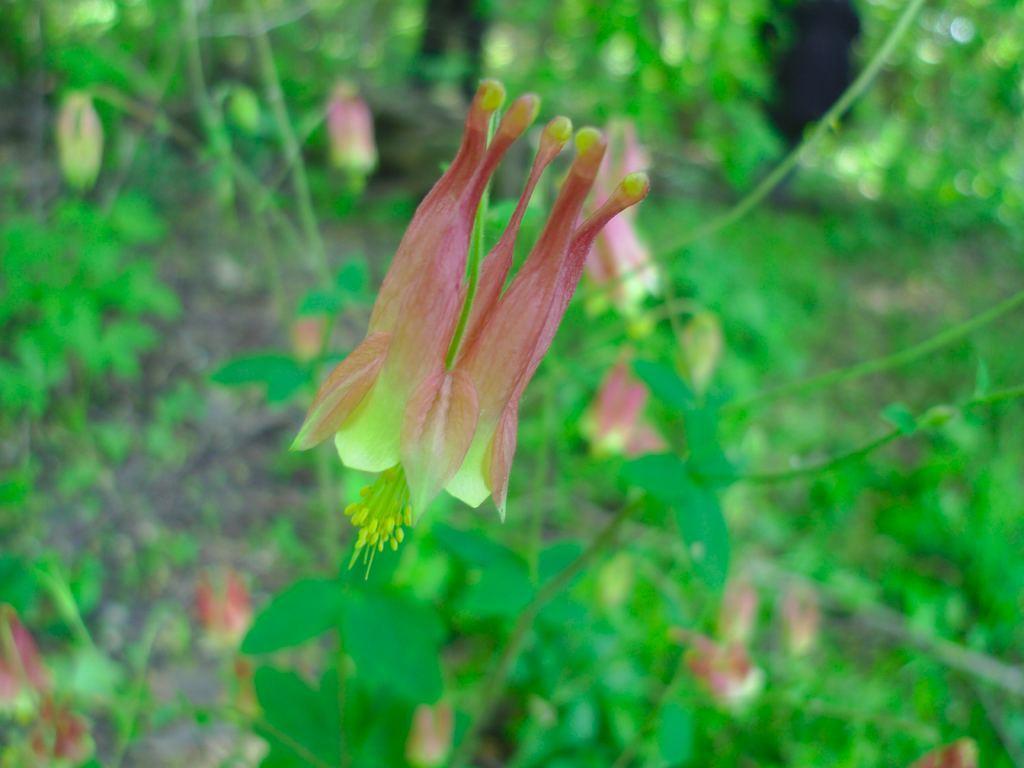Please provide a concise description of this image. Front side of image there is a flower having few petals. Behind the flower there are few plants having leaves and flowers to it. 